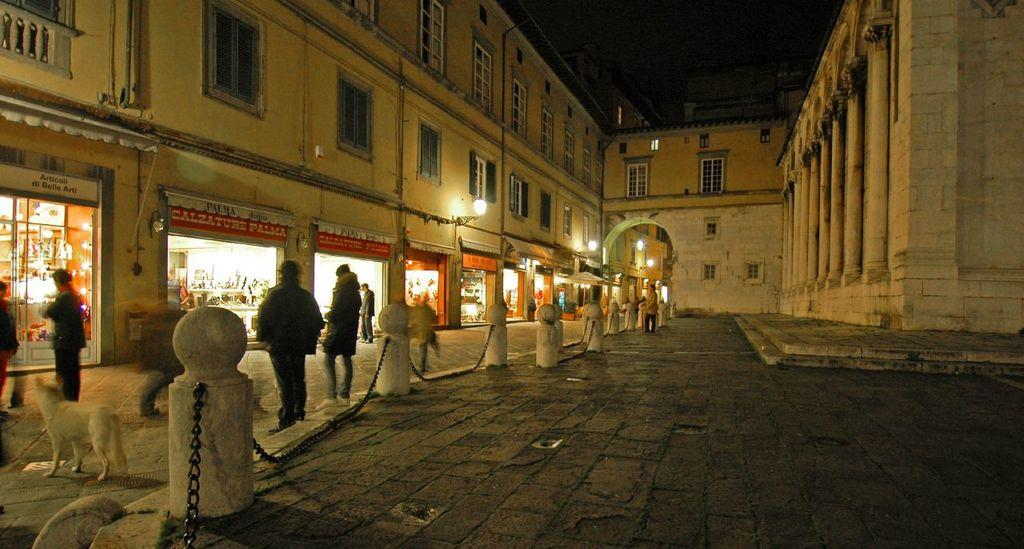<image>
Render a clear and concise summary of the photo. People walk on a sidewalk in front of stores like Calzature Palma. 